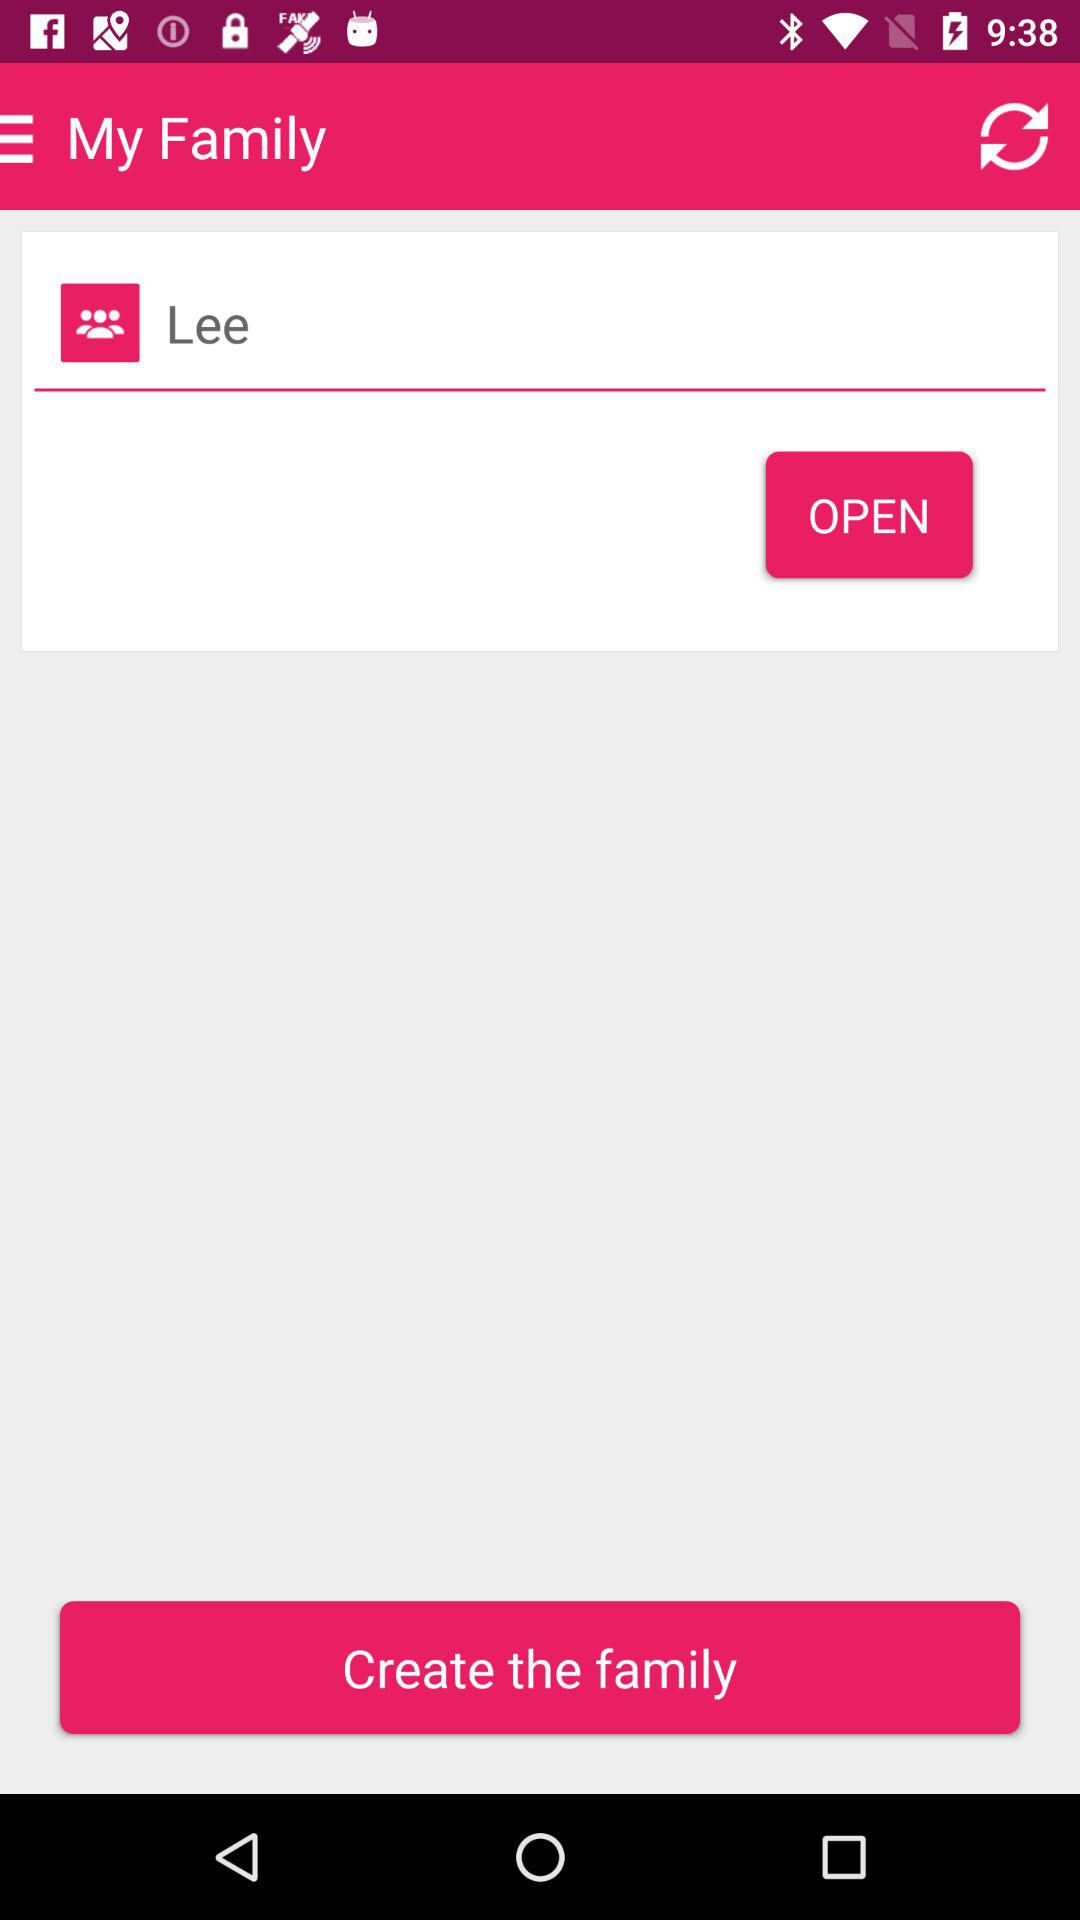What is the name of the family? The name of the family is "Lee". 